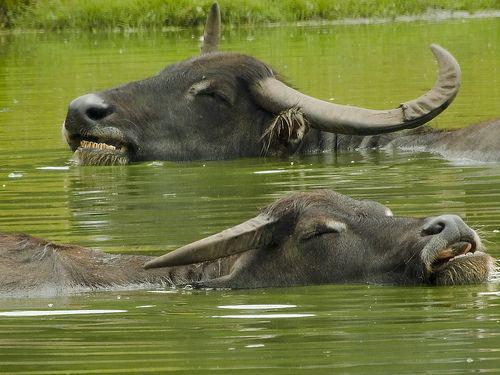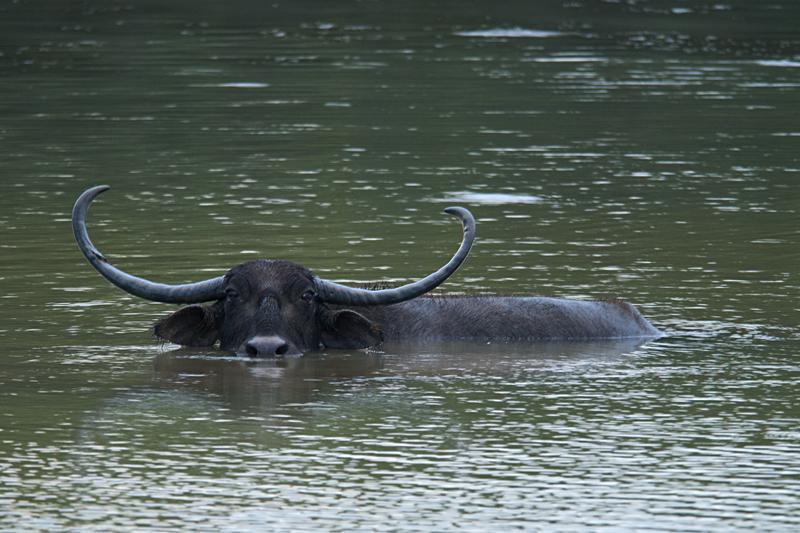The first image is the image on the left, the second image is the image on the right. Evaluate the accuracy of this statement regarding the images: "There are three animals in total.". Is it true? Answer yes or no. Yes. 